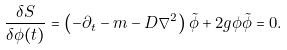Convert formula to latex. <formula><loc_0><loc_0><loc_500><loc_500>\frac { \delta S } { \delta \phi ( t ) } = \left ( - \partial _ { t } - m - D \nabla ^ { 2 } \right ) \tilde { \phi } + 2 g \phi \tilde { \phi } = 0 .</formula> 